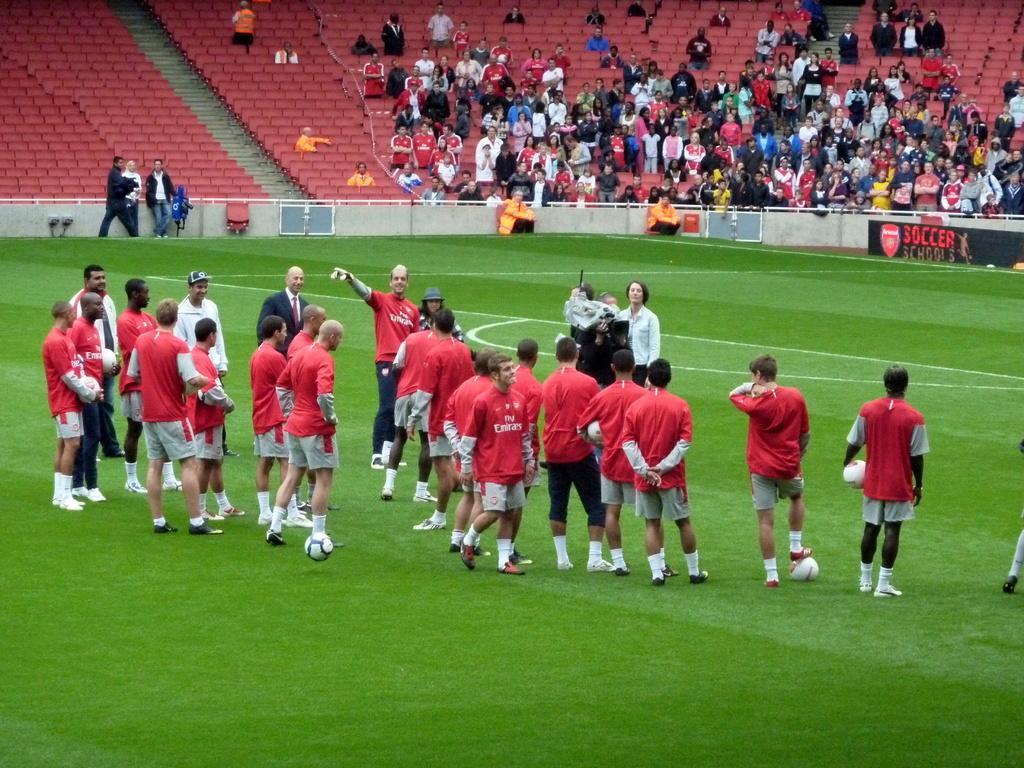Could you give a brief overview of what you see in this image? In the image there are many men standing on grass land, they all wore red t-shirts and grey shorts, this seems to be of football game, in there are many audience sitting on chairs and looking at the game. 